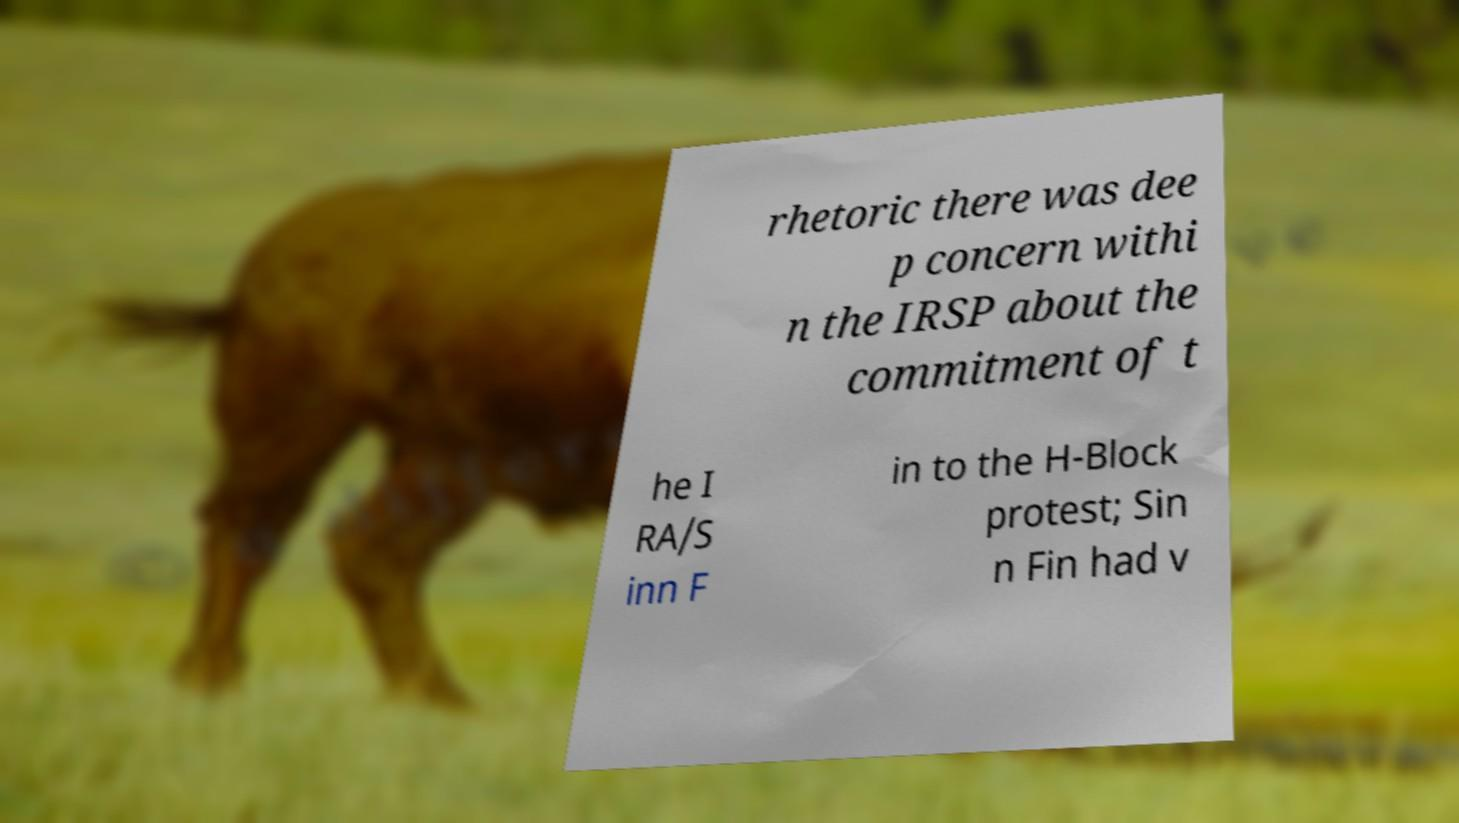Please read and relay the text visible in this image. What does it say? rhetoric there was dee p concern withi n the IRSP about the commitment of t he I RA/S inn F in to the H-Block protest; Sin n Fin had v 